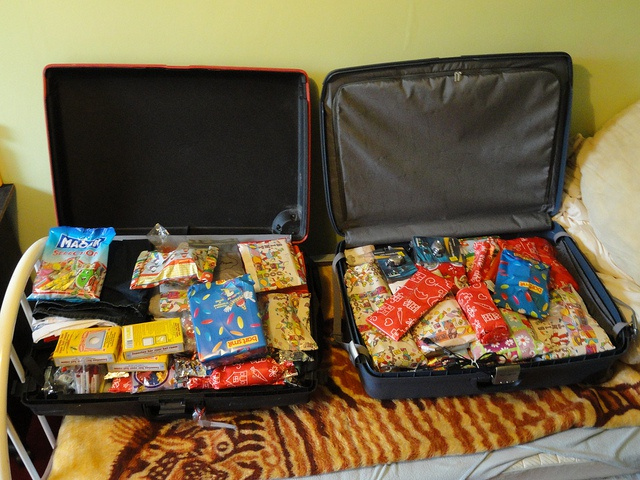Describe the objects in this image and their specific colors. I can see suitcase in khaki, black, darkgray, gray, and maroon tones, suitcase in khaki, black, gray, and maroon tones, and bed in khaki, black, brown, maroon, and darkgray tones in this image. 